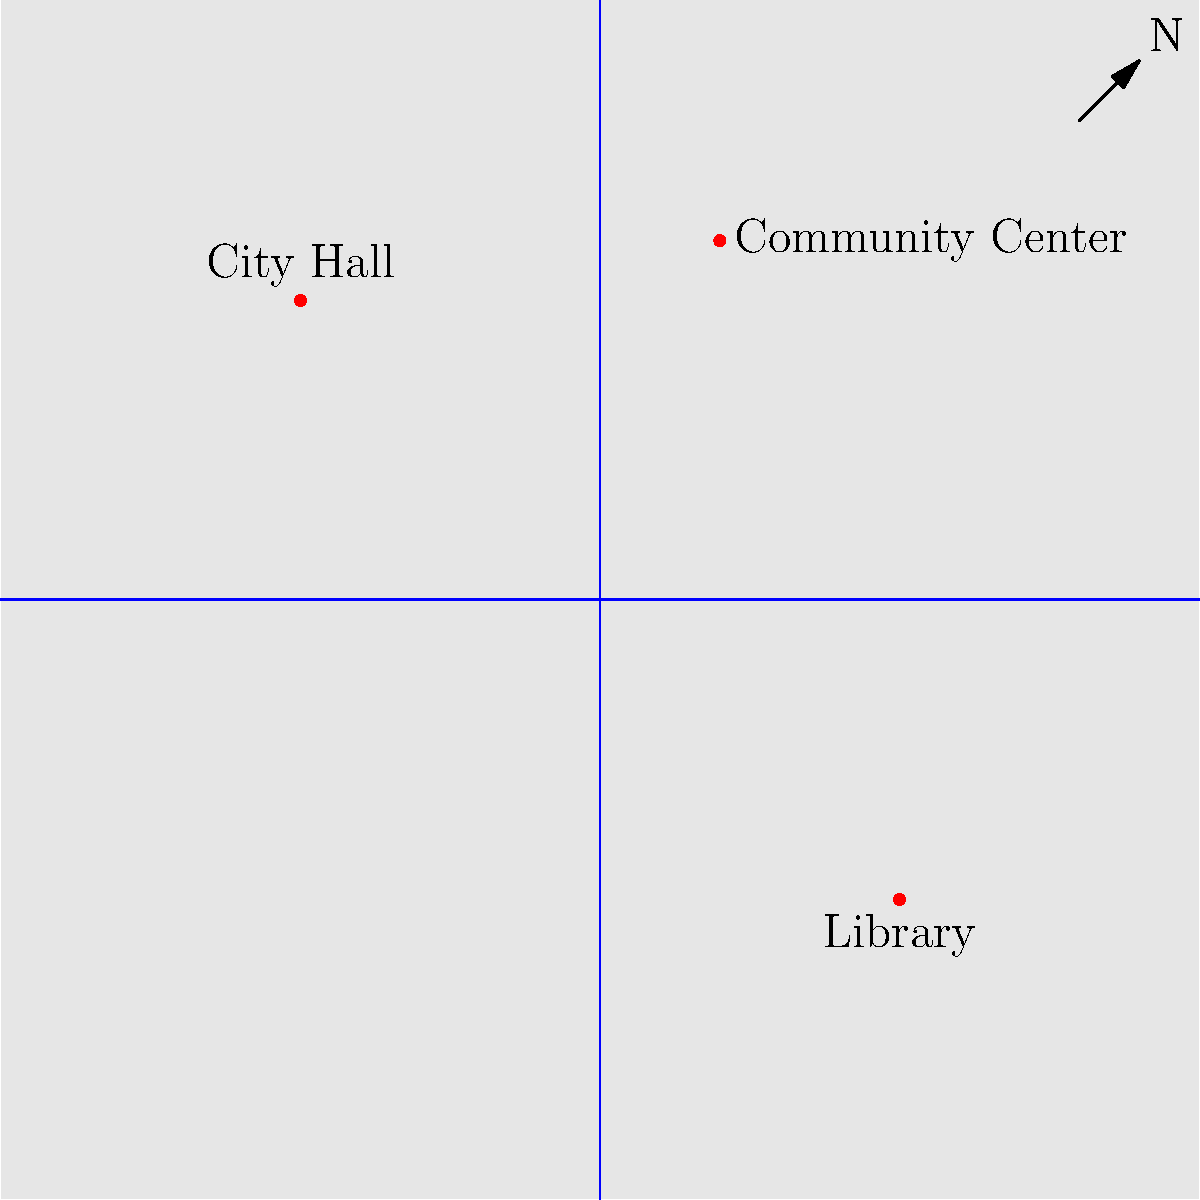Based on the map of New Bedford, which polling location is closest to the center of the city? To determine which polling location is closest to the center of the city, we need to follow these steps:

1. Identify the center of the map: The center of the map is at coordinates (50, 50), where the main streets intersect.

2. Locate the polling locations:
   a. City Hall: approximately at (25, 75)
   b. Library: approximately at (75, 25)
   c. Community Center: approximately at (60, 80)

3. Calculate the distance from each polling location to the center:
   We can use the distance formula: $d = \sqrt{(x_2-x_1)^2 + (y_2-y_1)^2}$

   a. City Hall: $d = \sqrt{(25-50)^2 + (75-50)^2} \approx 35.36$
   b. Library: $d = \sqrt{(75-50)^2 + (25-50)^2} \approx 35.36$
   c. Community Center: $d = \sqrt{(60-50)^2 + (80-50)^2} \approx 31.62$

4. Compare the distances:
   The Community Center has the shortest distance to the center of the map.

Therefore, the polling location closest to the center of the city is the Community Center.
Answer: Community Center 